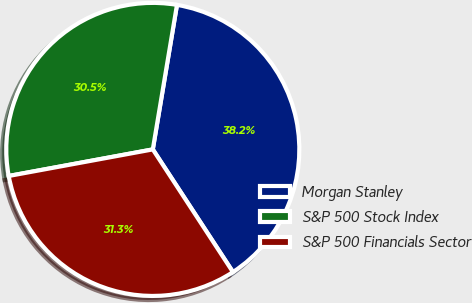<chart> <loc_0><loc_0><loc_500><loc_500><pie_chart><fcel>Morgan Stanley<fcel>S&P 500 Stock Index<fcel>S&P 500 Financials Sector<nl><fcel>38.15%<fcel>30.54%<fcel>31.31%<nl></chart> 